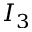Convert formula to latex. <formula><loc_0><loc_0><loc_500><loc_500>I _ { 3 }</formula> 